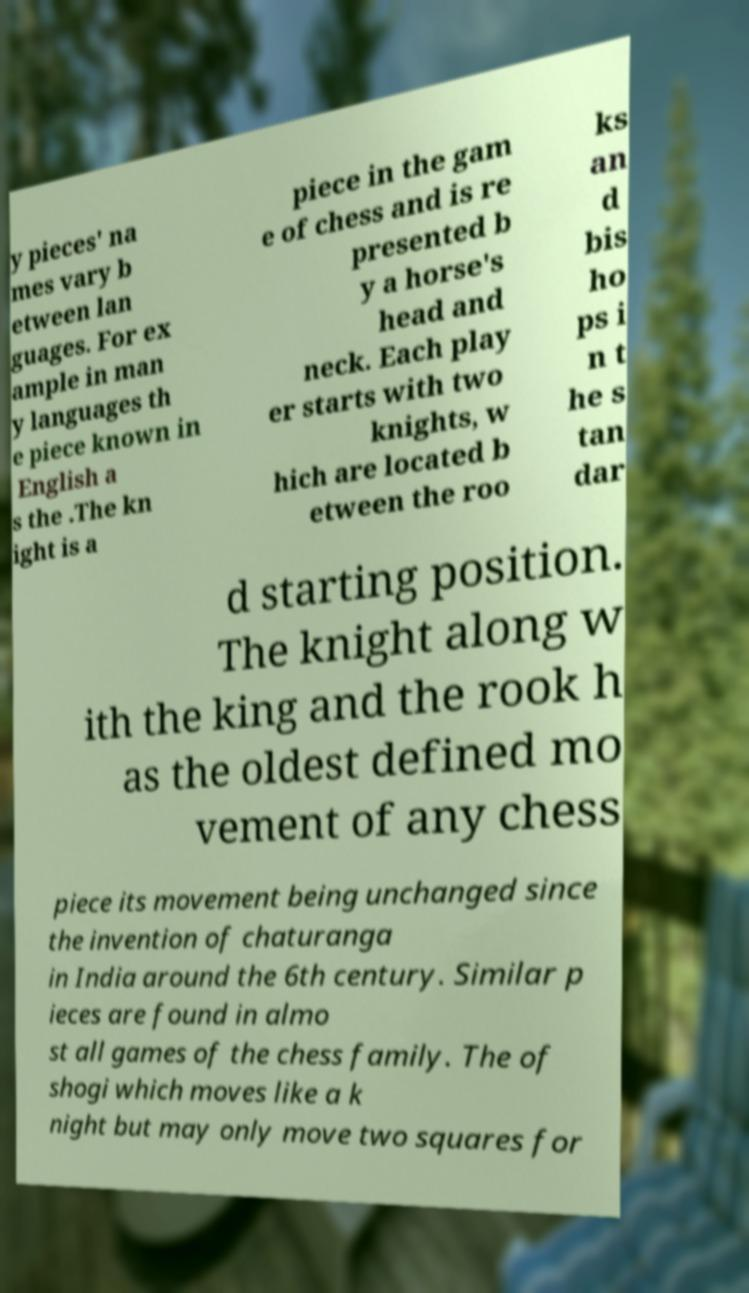For documentation purposes, I need the text within this image transcribed. Could you provide that? y pieces' na mes vary b etween lan guages. For ex ample in man y languages th e piece known in English a s the .The kn ight is a piece in the gam e of chess and is re presented b y a horse's head and neck. Each play er starts with two knights, w hich are located b etween the roo ks an d bis ho ps i n t he s tan dar d starting position. The knight along w ith the king and the rook h as the oldest defined mo vement of any chess piece its movement being unchanged since the invention of chaturanga in India around the 6th century. Similar p ieces are found in almo st all games of the chess family. The of shogi which moves like a k night but may only move two squares for 